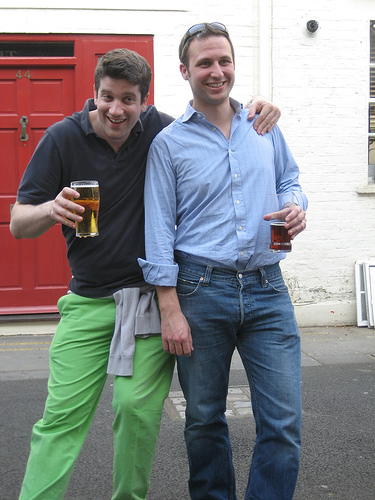<image>
Is the man on the beer? Yes. Looking at the image, I can see the man is positioned on top of the beer, with the beer providing support. Is the first man behind the second man? Yes. From this viewpoint, the first man is positioned behind the second man, with the second man partially or fully occluding the first man. 